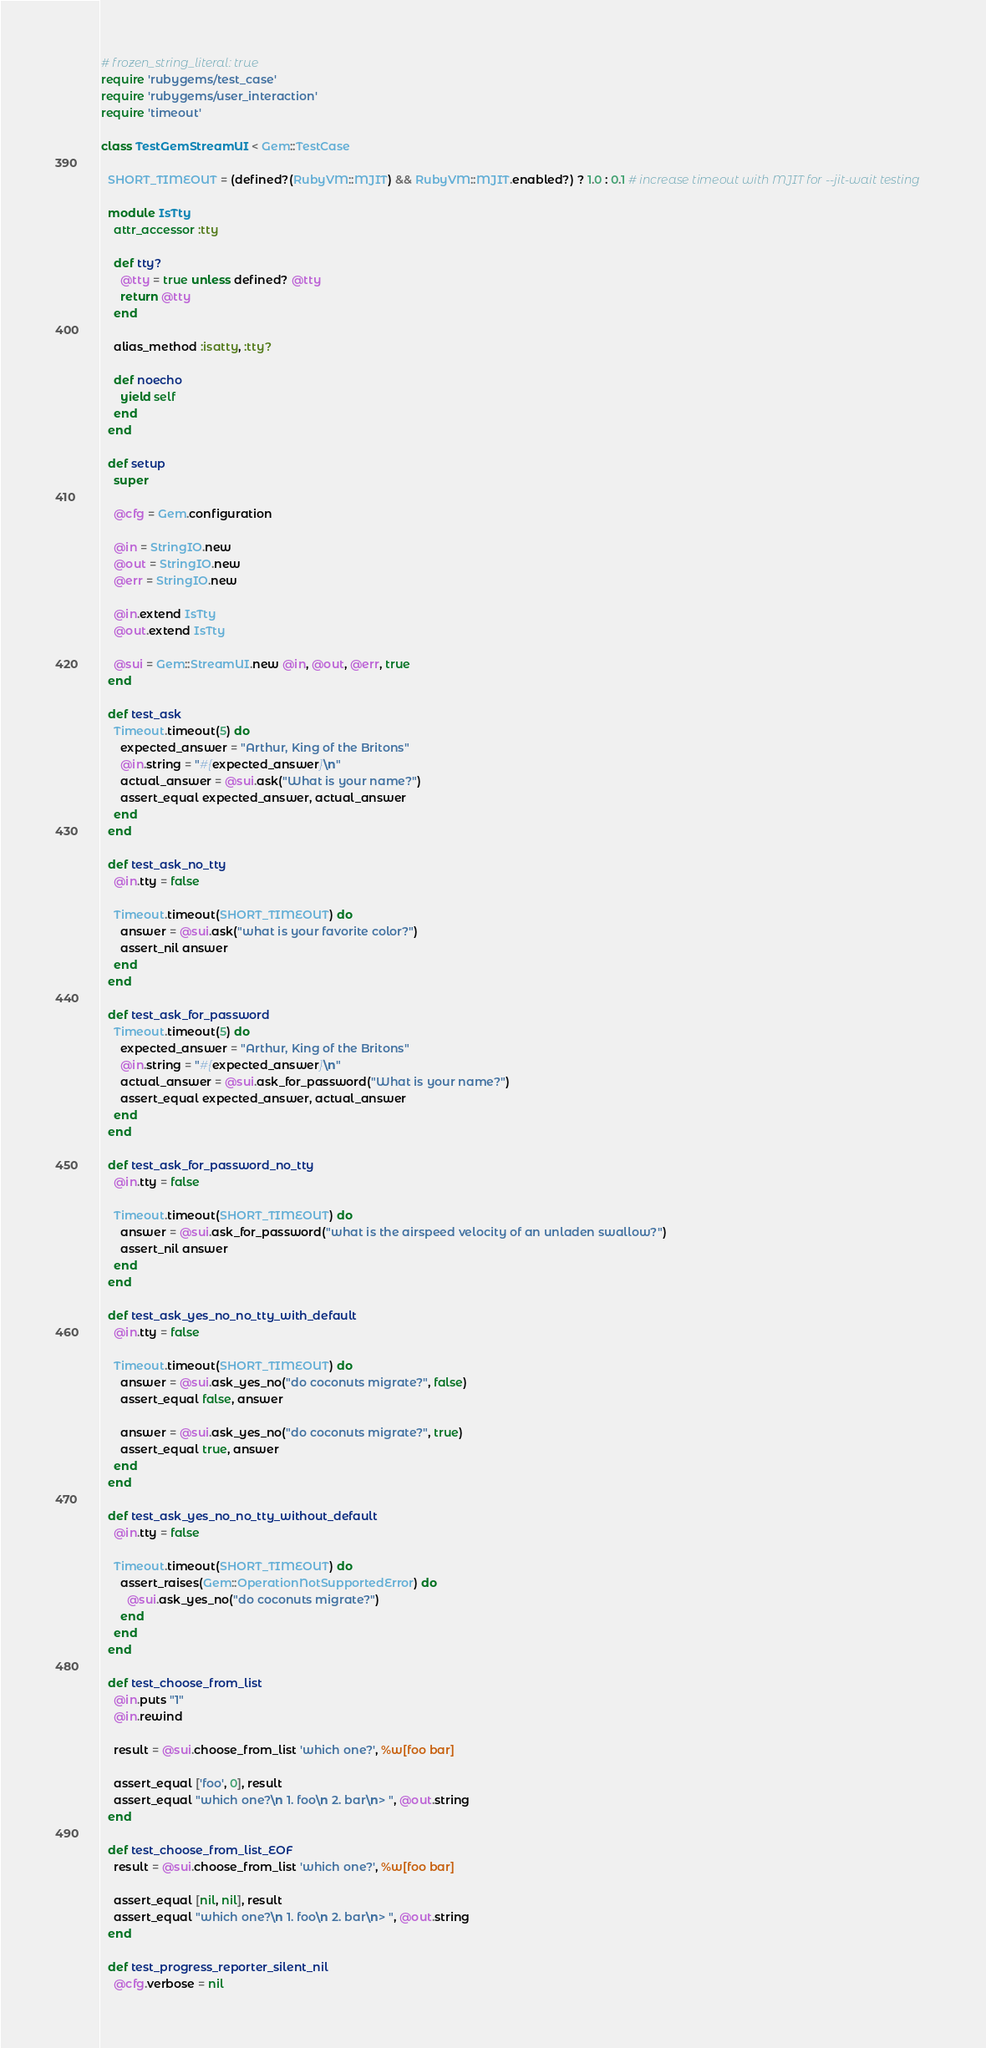Convert code to text. <code><loc_0><loc_0><loc_500><loc_500><_Ruby_># frozen_string_literal: true
require 'rubygems/test_case'
require 'rubygems/user_interaction'
require 'timeout'

class TestGemStreamUI < Gem::TestCase

  SHORT_TIMEOUT = (defined?(RubyVM::MJIT) && RubyVM::MJIT.enabled?) ? 1.0 : 0.1 # increase timeout with MJIT for --jit-wait testing

  module IsTty
    attr_accessor :tty

    def tty?
      @tty = true unless defined? @tty
      return @tty
    end

    alias_method :isatty, :tty?

    def noecho
      yield self
    end
  end

  def setup
    super

    @cfg = Gem.configuration

    @in = StringIO.new
    @out = StringIO.new
    @err = StringIO.new

    @in.extend IsTty
    @out.extend IsTty

    @sui = Gem::StreamUI.new @in, @out, @err, true
  end

  def test_ask
    Timeout.timeout(5) do
      expected_answer = "Arthur, King of the Britons"
      @in.string = "#{expected_answer}\n"
      actual_answer = @sui.ask("What is your name?")
      assert_equal expected_answer, actual_answer
    end
  end

  def test_ask_no_tty
    @in.tty = false

    Timeout.timeout(SHORT_TIMEOUT) do
      answer = @sui.ask("what is your favorite color?")
      assert_nil answer
    end
  end

  def test_ask_for_password
    Timeout.timeout(5) do
      expected_answer = "Arthur, King of the Britons"
      @in.string = "#{expected_answer}\n"
      actual_answer = @sui.ask_for_password("What is your name?")
      assert_equal expected_answer, actual_answer
    end
  end

  def test_ask_for_password_no_tty
    @in.tty = false

    Timeout.timeout(SHORT_TIMEOUT) do
      answer = @sui.ask_for_password("what is the airspeed velocity of an unladen swallow?")
      assert_nil answer
    end
  end

  def test_ask_yes_no_no_tty_with_default
    @in.tty = false

    Timeout.timeout(SHORT_TIMEOUT) do
      answer = @sui.ask_yes_no("do coconuts migrate?", false)
      assert_equal false, answer

      answer = @sui.ask_yes_no("do coconuts migrate?", true)
      assert_equal true, answer
    end
  end

  def test_ask_yes_no_no_tty_without_default
    @in.tty = false

    Timeout.timeout(SHORT_TIMEOUT) do
      assert_raises(Gem::OperationNotSupportedError) do
        @sui.ask_yes_no("do coconuts migrate?")
      end
    end
  end

  def test_choose_from_list
    @in.puts "1"
    @in.rewind

    result = @sui.choose_from_list 'which one?', %w[foo bar]

    assert_equal ['foo', 0], result
    assert_equal "which one?\n 1. foo\n 2. bar\n> ", @out.string
  end

  def test_choose_from_list_EOF
    result = @sui.choose_from_list 'which one?', %w[foo bar]

    assert_equal [nil, nil], result
    assert_equal "which one?\n 1. foo\n 2. bar\n> ", @out.string
  end

  def test_progress_reporter_silent_nil
    @cfg.verbose = nil</code> 